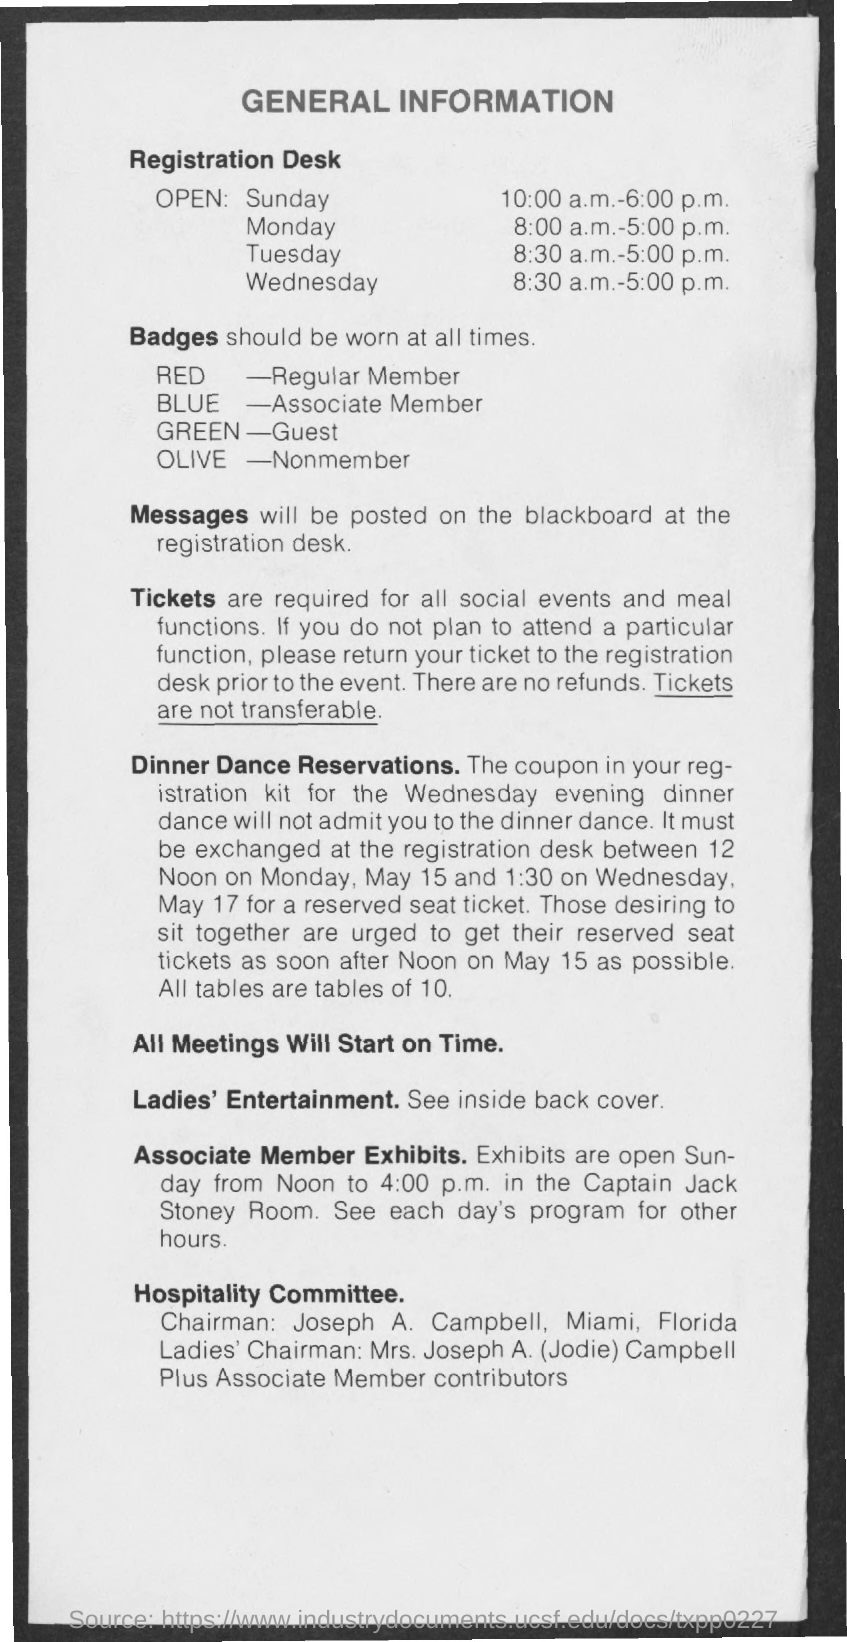What does the red badge indicates ?
Your answer should be very brief. Regular member. What does the blue badge indicates ?
Provide a succinct answer. Associate member. What does the green badge indicates ?
Ensure brevity in your answer.  Guest. What does the olive badge indicates ?
Provide a succinct answer. Nonmember. 